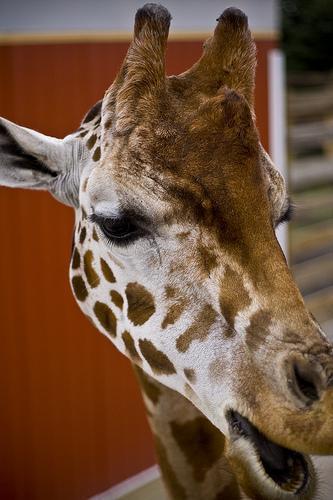How many giraffes are photographed?
Give a very brief answer. 1. 